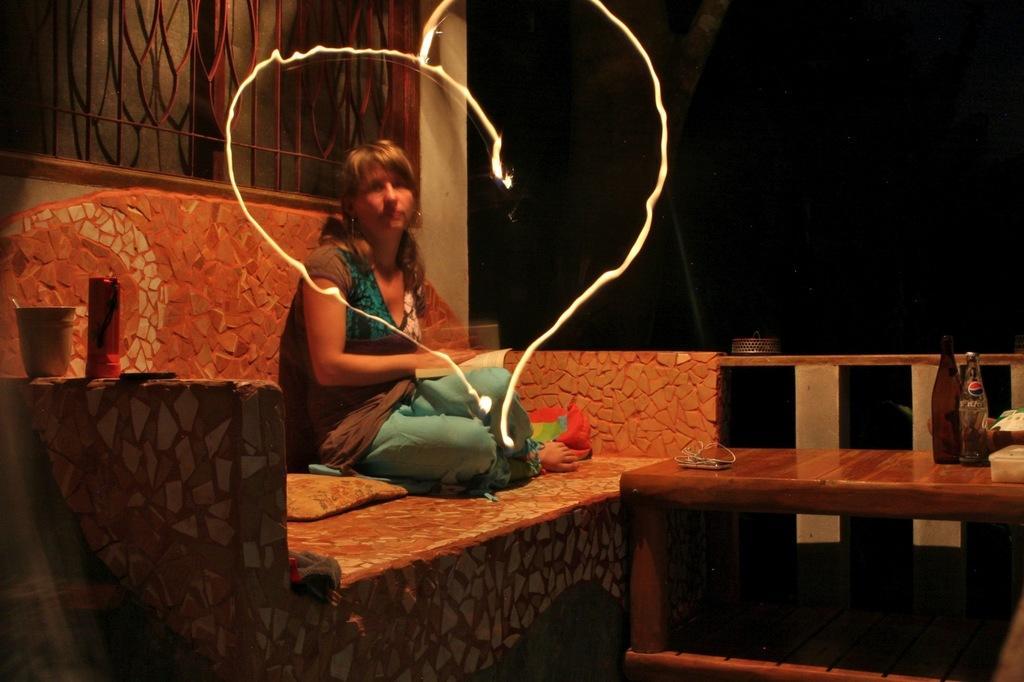Describe this image in one or two sentences. A woman is sitting behind her there is a window. On the right side there are bottles on a table. 